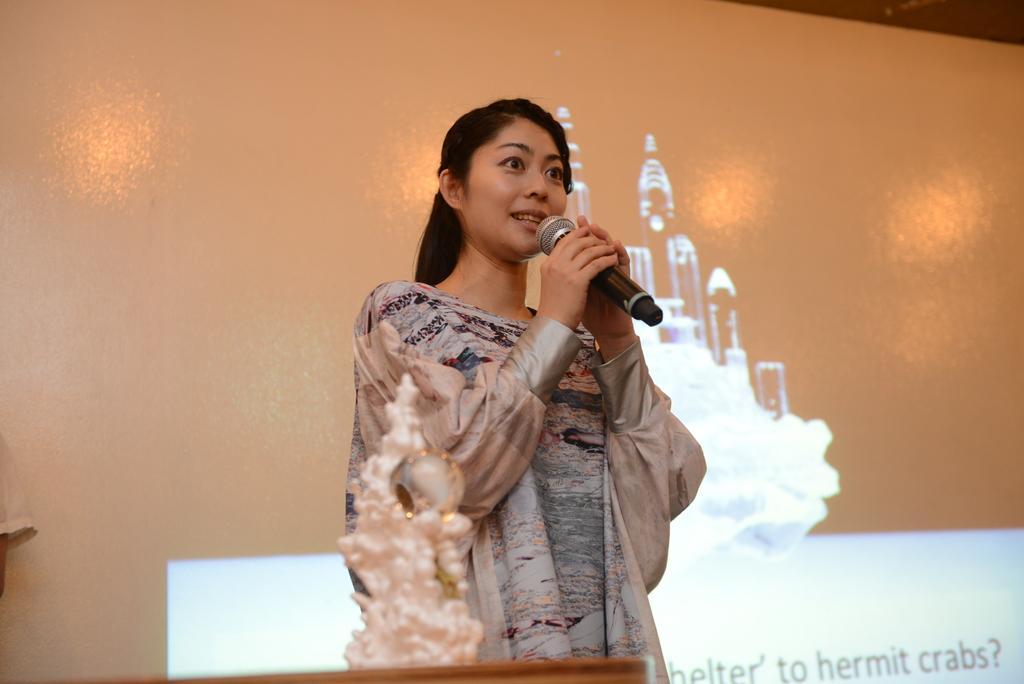Could you give a brief overview of what you see in this image? In this picture we can see a woman standing and holding a mike in her hand and talking. On the background we can see a wall and a board. 